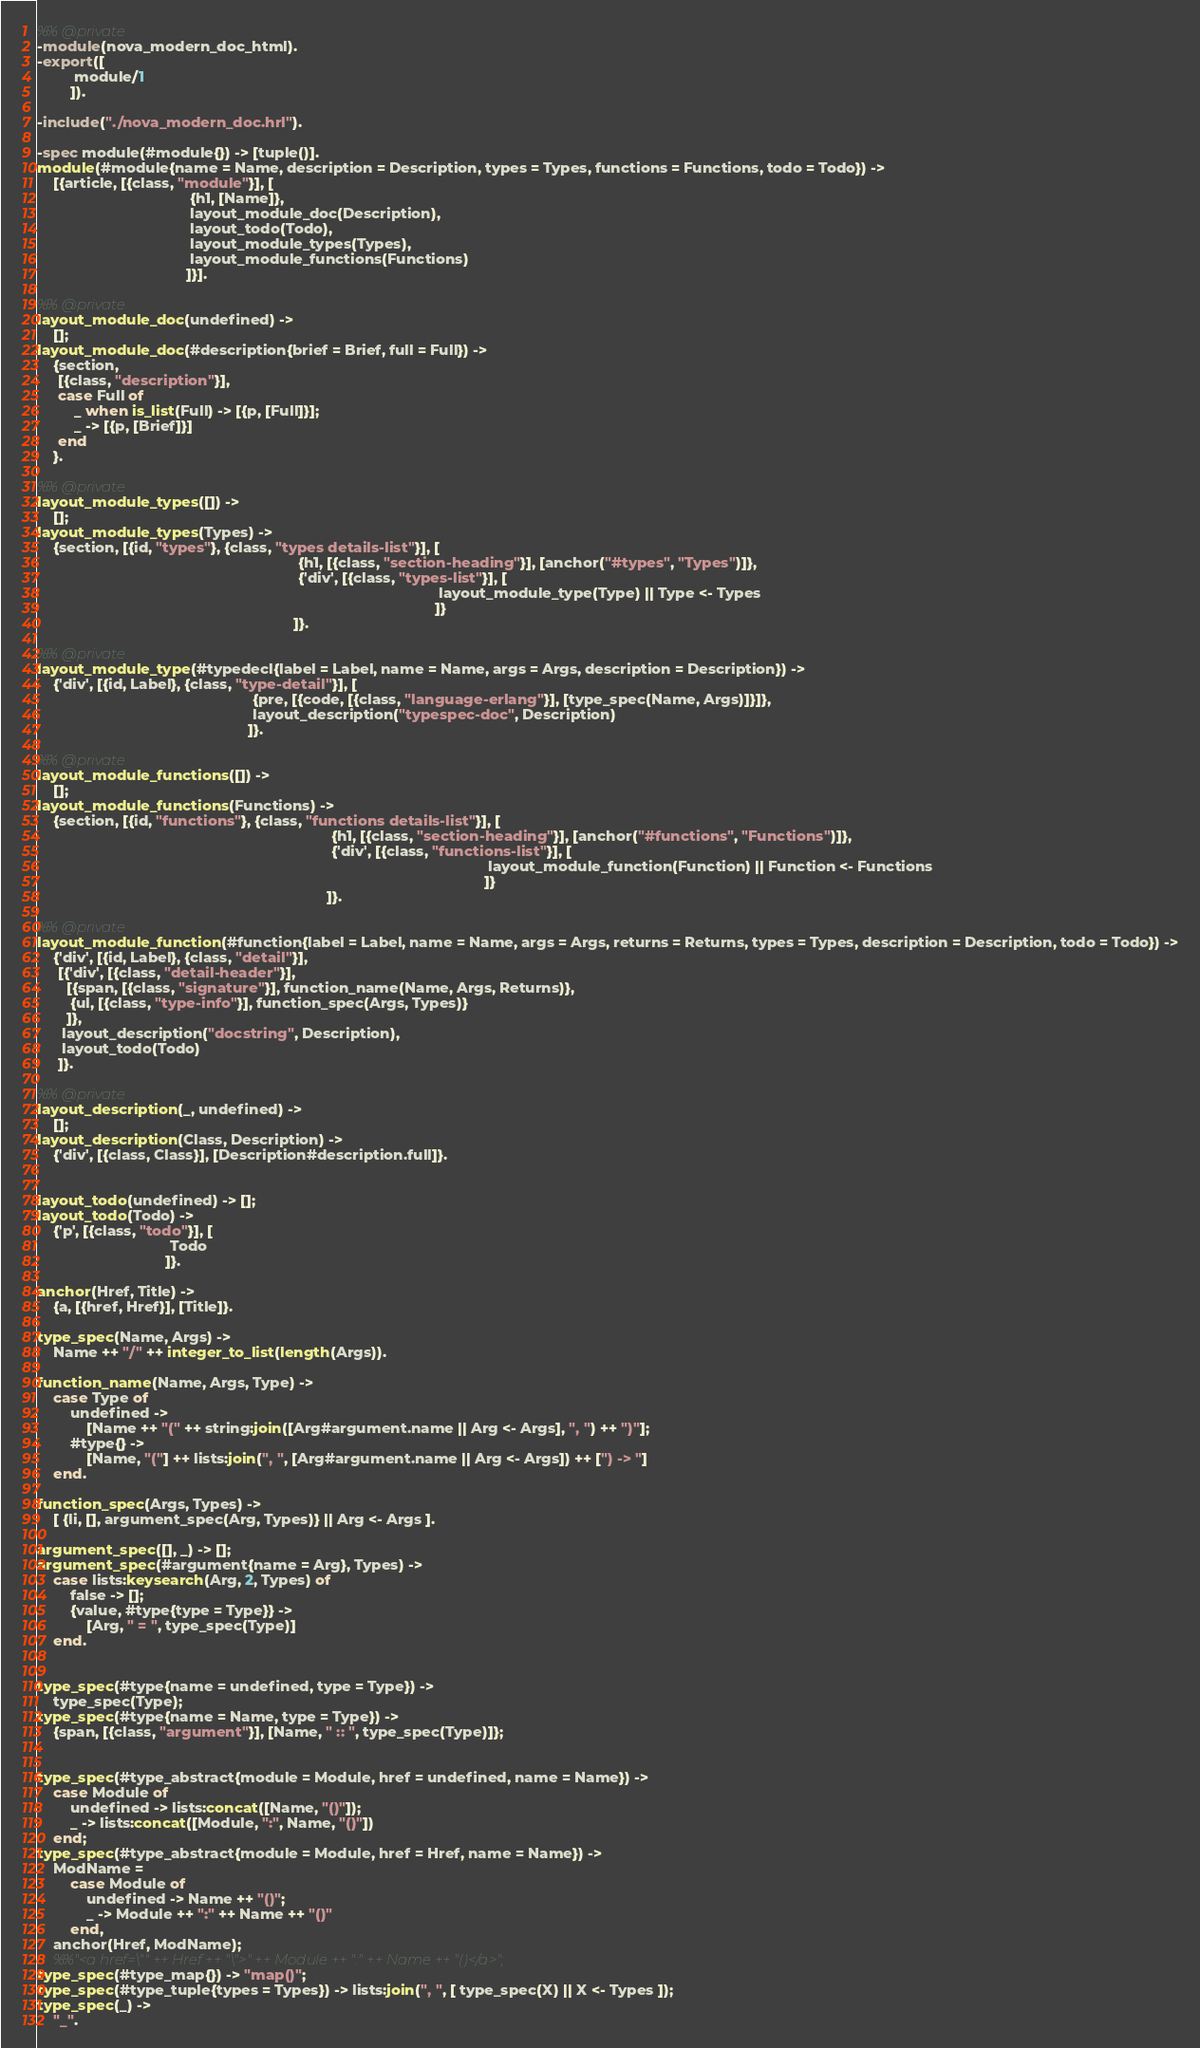<code> <loc_0><loc_0><loc_500><loc_500><_Erlang_>%% @private
-module(nova_modern_doc_html).
-export([
         module/1
        ]).

-include("./nova_modern_doc.hrl").

-spec module(#module{}) -> [tuple()].
module(#module{name = Name, description = Description, types = Types, functions = Functions, todo = Todo}) ->
    [{article, [{class, "module"}], [
                                     {h1, [Name]},
                                     layout_module_doc(Description),
                                     layout_todo(Todo),
                                     layout_module_types(Types),
                                     layout_module_functions(Functions)
                                    ]}].

%% @private
layout_module_doc(undefined) ->
    [];
layout_module_doc(#description{brief = Brief, full = Full}) ->
    {section,
     [{class, "description"}],
     case Full of
         _ when is_list(Full) -> [{p, [Full]}];
         _ -> [{p, [Brief]}]
     end
    }.

%% @private
layout_module_types([]) ->
    [];
layout_module_types(Types) ->
    {section, [{id, "types"}, {class, "types details-list"}], [
                                                               {h1, [{class, "section-heading"}], [anchor("#types", "Types")]},
                                                               {'div', [{class, "types-list"}], [
                                                                                                 layout_module_type(Type) || Type <- Types
                                                                                                ]}
                                                              ]}.

%% @private
layout_module_type(#typedecl{label = Label, name = Name, args = Args, description = Description}) ->
    {'div', [{id, Label}, {class, "type-detail"}], [
                                                    {pre, [{code, [{class, "language-erlang"}], [type_spec(Name, Args)]}]},
                                                    layout_description("typespec-doc", Description)
                                                   ]}.

%% @private
layout_module_functions([]) ->
    [];
layout_module_functions(Functions) ->
    {section, [{id, "functions"}, {class, "functions details-list"}], [
                                                                       {h1, [{class, "section-heading"}], [anchor("#functions", "Functions")]},
                                                                       {'div', [{class, "functions-list"}], [
                                                                                                             layout_module_function(Function) || Function <- Functions
                                                                                                            ]}
                                                                      ]}.

%% @private
layout_module_function(#function{label = Label, name = Name, args = Args, returns = Returns, types = Types, description = Description, todo = Todo}) ->
    {'div', [{id, Label}, {class, "detail"}],
     [{'div', [{class, "detail-header"}],
       [{span, [{class, "signature"}], function_name(Name, Args, Returns)},
        {ul, [{class, "type-info"}], function_spec(Args, Types)}
       ]},
      layout_description("docstring", Description),
      layout_todo(Todo)
     ]}.

%% @private
layout_description(_, undefined) ->
    [];
layout_description(Class, Description) ->
    {'div', [{class, Class}], [Description#description.full]}.


layout_todo(undefined) -> [];
layout_todo(Todo) ->
    {'p', [{class, "todo"}], [
                                Todo
                               ]}.

anchor(Href, Title) ->
    {a, [{href, Href}], [Title]}.

type_spec(Name, Args) ->
    Name ++ "/" ++ integer_to_list(length(Args)).

function_name(Name, Args, Type) ->
    case Type of
        undefined ->
            [Name ++ "(" ++ string:join([Arg#argument.name || Arg <- Args], ", ") ++ ")"];
        #type{} ->
            [Name, "("] ++ lists:join(", ", [Arg#argument.name || Arg <- Args]) ++ [") -> "]
    end.

function_spec(Args, Types) ->
    [ {li, [], argument_spec(Arg, Types)} || Arg <- Args ].

argument_spec([], _) -> [];
argument_spec(#argument{name = Arg}, Types) ->
    case lists:keysearch(Arg, 2, Types) of
        false -> [];
        {value, #type{type = Type}} ->
            [Arg, " = ", type_spec(Type)]
    end.


type_spec(#type{name = undefined, type = Type}) ->
    type_spec(Type);
type_spec(#type{name = Name, type = Type}) ->
    {span, [{class, "argument"}], [Name, " :: ", type_spec(Type)]};


type_spec(#type_abstract{module = Module, href = undefined, name = Name}) ->
    case Module of
        undefined -> lists:concat([Name, "()"]);
        _ -> lists:concat([Module, ":", Name, "()"])
    end;
type_spec(#type_abstract{module = Module, href = Href, name = Name}) ->
    ModName =
        case Module of
            undefined -> Name ++ "()";
            _ -> Module ++ ":" ++ Name ++ "()"
        end,
    anchor(Href, ModName);
    %%"<a href=\"" ++ Href ++ "\">" ++ Module ++ ":" ++ Name ++ "()</a>";
type_spec(#type_map{}) -> "map()";
type_spec(#type_tuple{types = Types}) -> lists:join(", ", [ type_spec(X) || X <- Types ]);
type_spec(_) ->
    "_".
</code> 